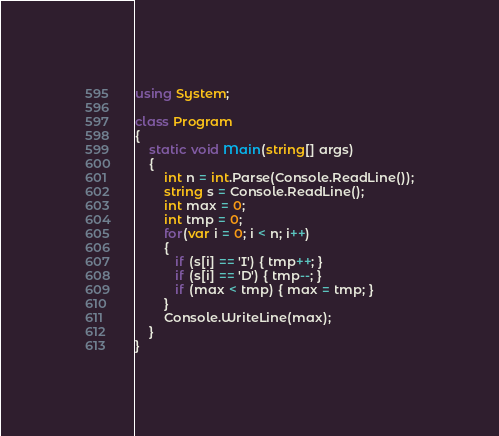Convert code to text. <code><loc_0><loc_0><loc_500><loc_500><_C#_>using System;

class Program
{
	static void Main(string[] args)
    {
    	int n = int.Parse(Console.ReadLine());
        string s = Console.ReadLine();
      	int max = 0;
        int tmp = 0;
        for(var i = 0; i < n; i++)
        {
           if (s[i] == 'I') { tmp++; }
           if (s[i] == 'D') { tmp--; }
           if (max < tmp) { max = tmp; }
        }
        Console.WriteLine(max);
    }
}</code> 